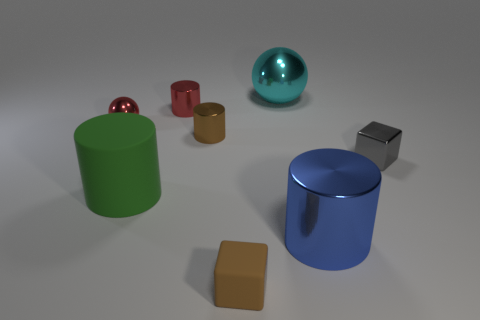Add 1 gray metal objects. How many objects exist? 9 Subtract all balls. How many objects are left? 6 Add 7 large metal cylinders. How many large metal cylinders are left? 8 Add 8 tiny gray metal things. How many tiny gray metal things exist? 9 Subtract 0 yellow balls. How many objects are left? 8 Subtract all gray metal cylinders. Subtract all rubber objects. How many objects are left? 6 